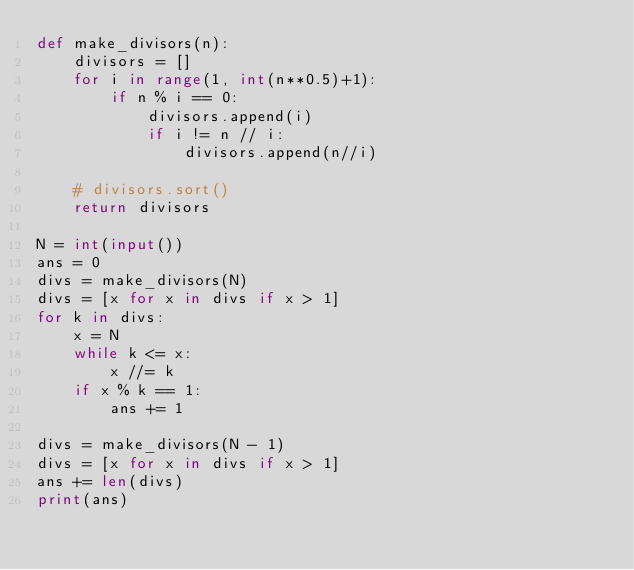Convert code to text. <code><loc_0><loc_0><loc_500><loc_500><_Python_>def make_divisors(n):
    divisors = []
    for i in range(1, int(n**0.5)+1):
        if n % i == 0:
            divisors.append(i)
            if i != n // i:
                divisors.append(n//i)

    # divisors.sort()
    return divisors

N = int(input())
ans = 0
divs = make_divisors(N)
divs = [x for x in divs if x > 1]
for k in divs:
    x = N
    while k <= x:
        x //= k
    if x % k == 1:
        ans += 1

divs = make_divisors(N - 1)
divs = [x for x in divs if x > 1]
ans += len(divs)
print(ans)
</code> 